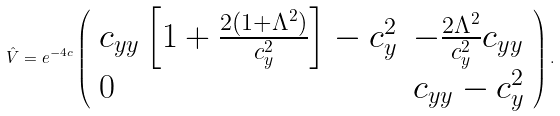Convert formula to latex. <formula><loc_0><loc_0><loc_500><loc_500>\hat { V } = e ^ { - 4 c } \left ( \begin{array} { l l } c _ { y y } \left [ 1 + \frac { 2 ( 1 + \Lambda ^ { 2 } ) } { c _ { y } ^ { 2 } } \right ] - c _ { y } ^ { 2 } & - \frac { 2 \Lambda ^ { 2 } } { c _ { y } ^ { 2 } } c _ { y y } \\ 0 & c _ { y y } - c _ { y } ^ { 2 } \end{array} \right ) .</formula> 